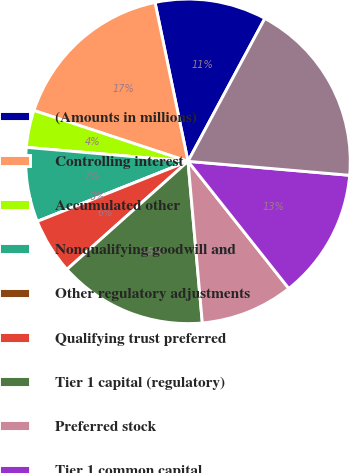Convert chart to OTSL. <chart><loc_0><loc_0><loc_500><loc_500><pie_chart><fcel>(Amounts in millions)<fcel>Controlling interest<fcel>Accumulated other<fcel>Nonqualifying goodwill and<fcel>Other regulatory adjustments<fcel>Qualifying trust preferred<fcel>Tier 1 capital (regulatory)<fcel>Preferred stock<fcel>Tier 1 common capital<fcel>Risk-weighted assets<nl><fcel>11.11%<fcel>16.67%<fcel>3.7%<fcel>7.41%<fcel>0.0%<fcel>5.56%<fcel>14.81%<fcel>9.26%<fcel>12.96%<fcel>18.52%<nl></chart> 